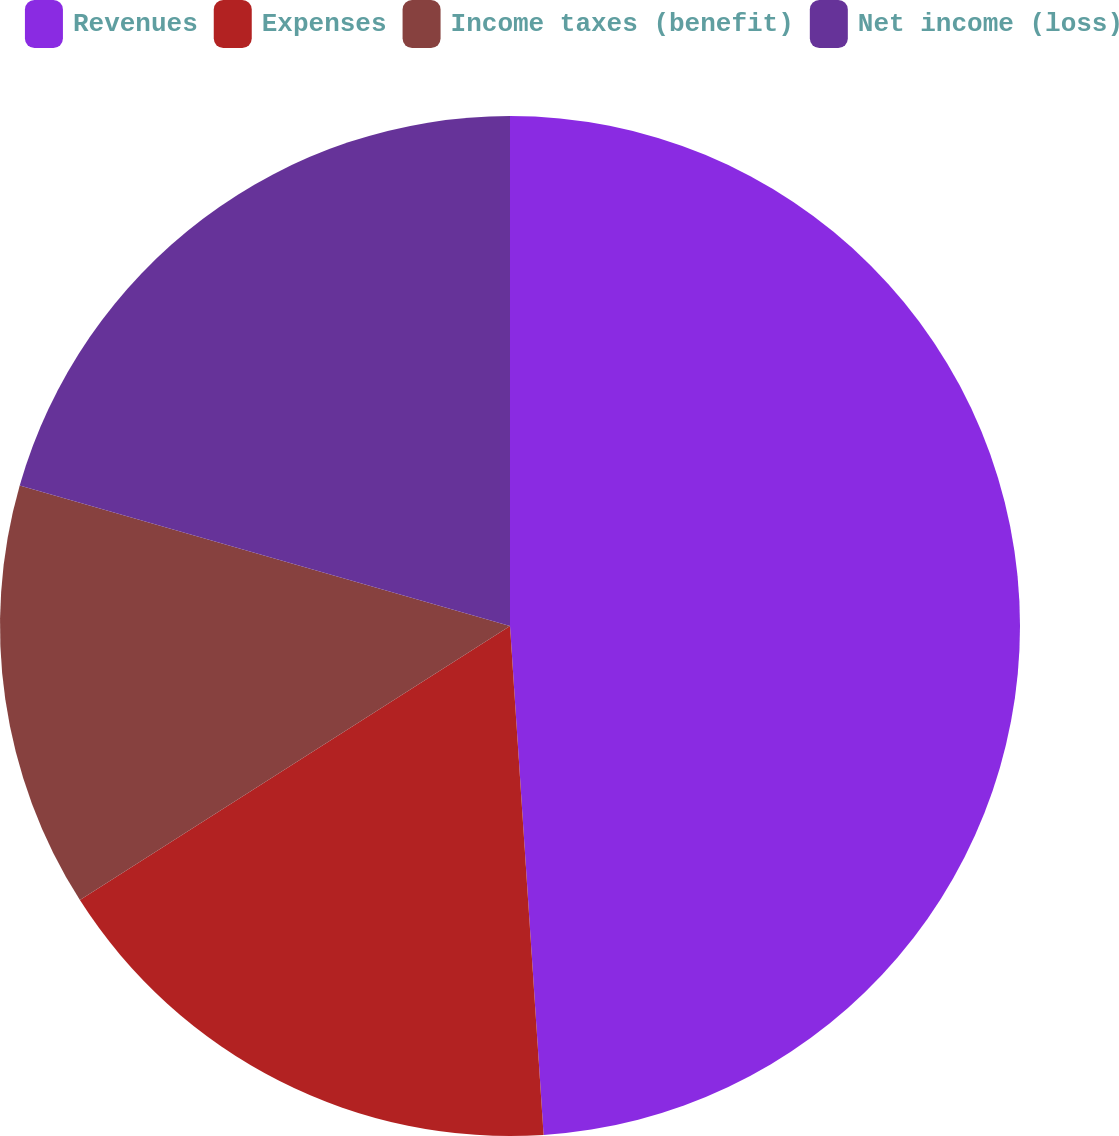<chart> <loc_0><loc_0><loc_500><loc_500><pie_chart><fcel>Revenues<fcel>Expenses<fcel>Income taxes (benefit)<fcel>Net income (loss)<nl><fcel>48.95%<fcel>17.02%<fcel>13.47%<fcel>20.56%<nl></chart> 